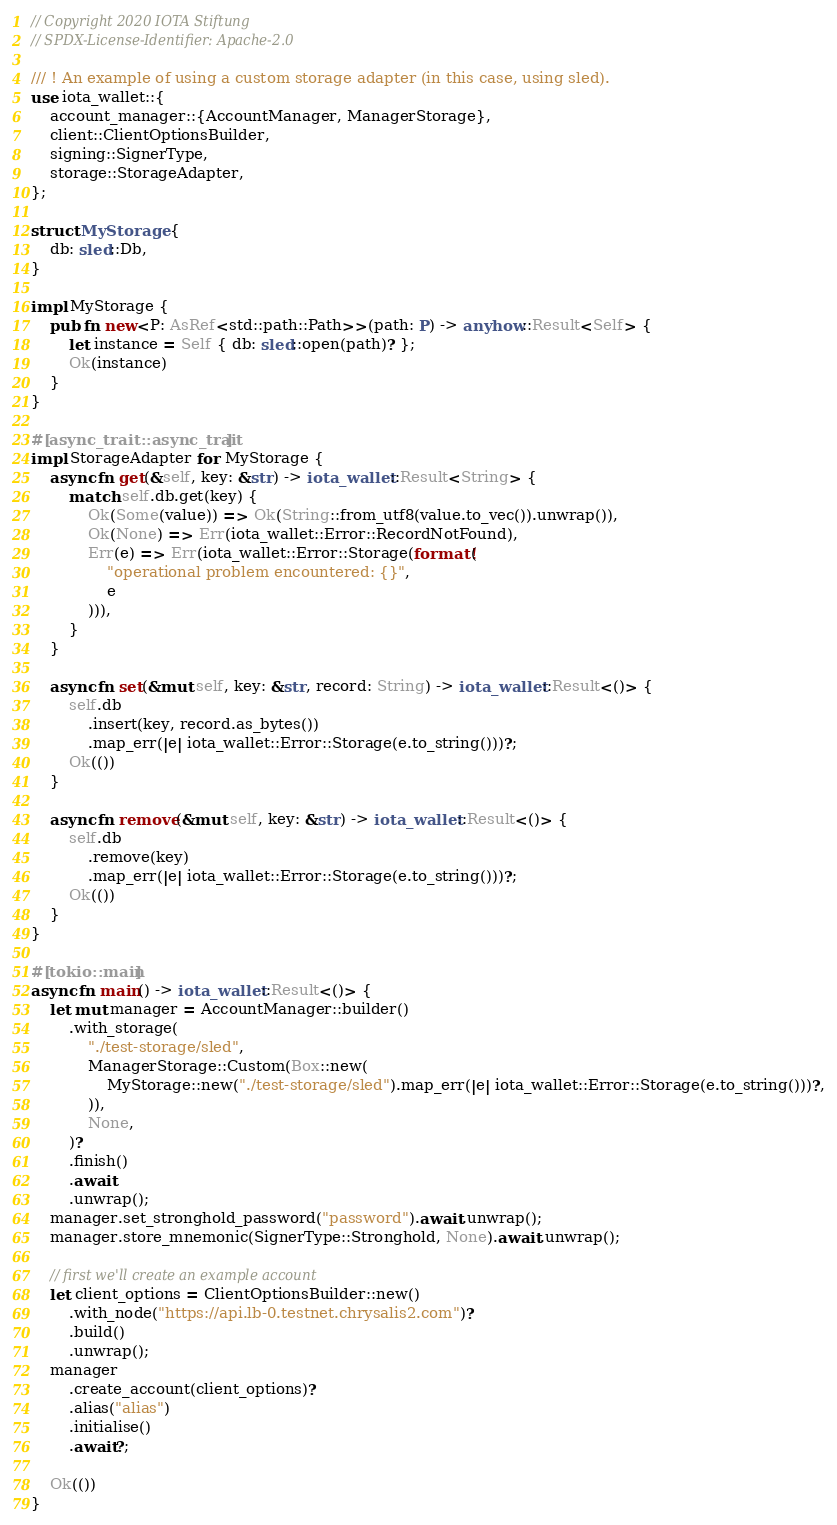<code> <loc_0><loc_0><loc_500><loc_500><_Rust_>// Copyright 2020 IOTA Stiftung
// SPDX-License-Identifier: Apache-2.0

/// ! An example of using a custom storage adapter (in this case, using sled).
use iota_wallet::{
    account_manager::{AccountManager, ManagerStorage},
    client::ClientOptionsBuilder,
    signing::SignerType,
    storage::StorageAdapter,
};

struct MyStorage {
    db: sled::Db,
}

impl MyStorage {
    pub fn new<P: AsRef<std::path::Path>>(path: P) -> anyhow::Result<Self> {
        let instance = Self { db: sled::open(path)? };
        Ok(instance)
    }
}

#[async_trait::async_trait]
impl StorageAdapter for MyStorage {
    async fn get(&self, key: &str) -> iota_wallet::Result<String> {
        match self.db.get(key) {
            Ok(Some(value)) => Ok(String::from_utf8(value.to_vec()).unwrap()),
            Ok(None) => Err(iota_wallet::Error::RecordNotFound),
            Err(e) => Err(iota_wallet::Error::Storage(format!(
                "operational problem encountered: {}",
                e
            ))),
        }
    }

    async fn set(&mut self, key: &str, record: String) -> iota_wallet::Result<()> {
        self.db
            .insert(key, record.as_bytes())
            .map_err(|e| iota_wallet::Error::Storage(e.to_string()))?;
        Ok(())
    }

    async fn remove(&mut self, key: &str) -> iota_wallet::Result<()> {
        self.db
            .remove(key)
            .map_err(|e| iota_wallet::Error::Storage(e.to_string()))?;
        Ok(())
    }
}

#[tokio::main]
async fn main() -> iota_wallet::Result<()> {
    let mut manager = AccountManager::builder()
        .with_storage(
            "./test-storage/sled",
            ManagerStorage::Custom(Box::new(
                MyStorage::new("./test-storage/sled").map_err(|e| iota_wallet::Error::Storage(e.to_string()))?,
            )),
            None,
        )?
        .finish()
        .await
        .unwrap();
    manager.set_stronghold_password("password").await.unwrap();
    manager.store_mnemonic(SignerType::Stronghold, None).await.unwrap();

    // first we'll create an example account
    let client_options = ClientOptionsBuilder::new()
        .with_node("https://api.lb-0.testnet.chrysalis2.com")?
        .build()
        .unwrap();
    manager
        .create_account(client_options)?
        .alias("alias")
        .initialise()
        .await?;

    Ok(())
}
</code> 